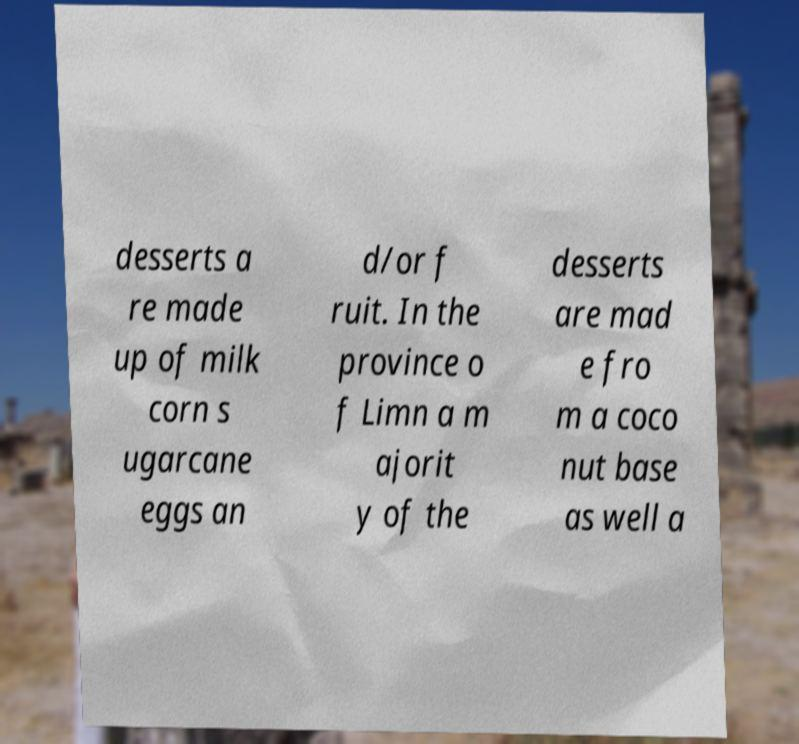I need the written content from this picture converted into text. Can you do that? desserts a re made up of milk corn s ugarcane eggs an d/or f ruit. In the province o f Limn a m ajorit y of the desserts are mad e fro m a coco nut base as well a 